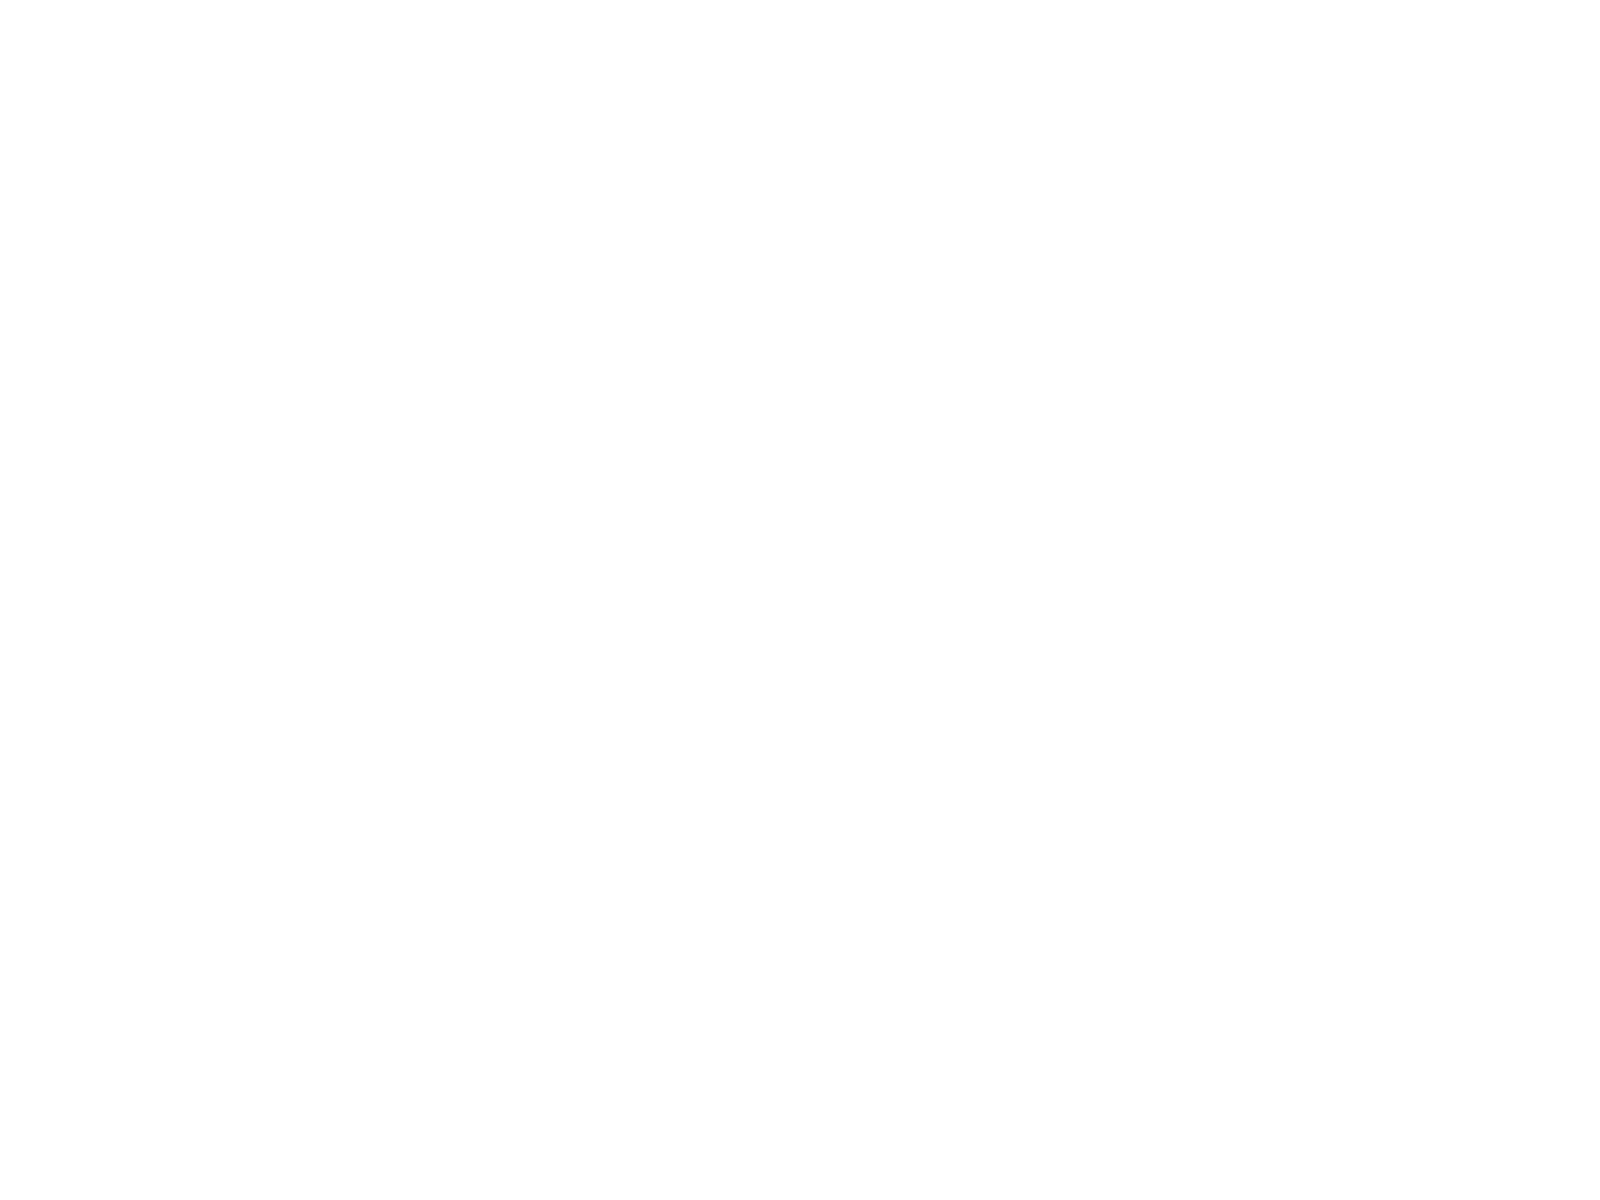<chart> <loc_0><loc_0><loc_500><loc_500><pie_chart><fcel>Total deposit spreads<fcel>Client brokerage assets (in<fcel>Digital banking active users<fcel>Mobile banking active users<fcel>Financial centers<fcel>ATMs<nl><fcel>0.0%<fcel>50.0%<fcel>20.0%<fcel>15.0%<fcel>5.0%<fcel>10.0%<nl></chart> 